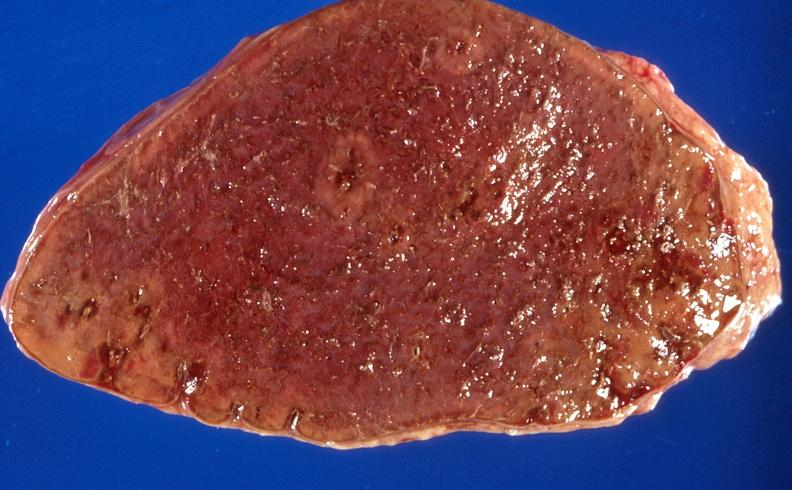what is present?
Answer the question using a single word or phrase. Hematologic 